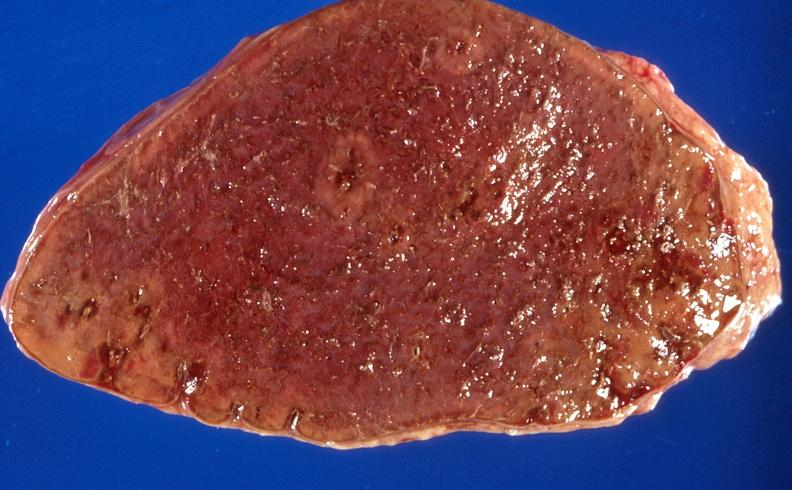what is present?
Answer the question using a single word or phrase. Hematologic 